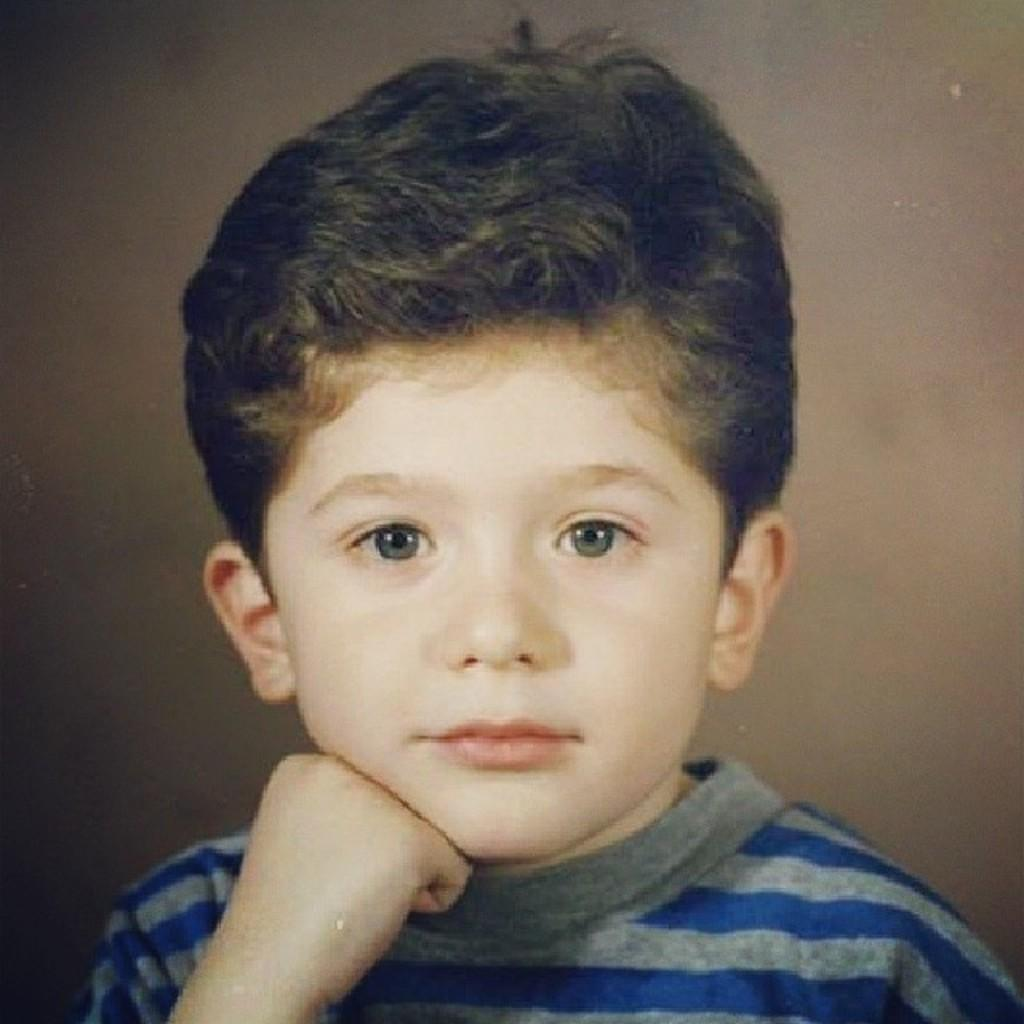Who is the main subject in the image? There is a boy in the image. What is located behind the boy in the image? There is a wall behind the boy in the image. What type of wax can be seen melting on the wall behind the boy in the image? There is no wax present in the image, and therefore no such activity can be observed. 